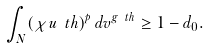Convert formula to latex. <formula><loc_0><loc_0><loc_500><loc_500>\int _ { N } ( \chi u _ { \ } t h ) ^ { p } \, d v ^ { g _ { \ } t h } \geq 1 - d _ { 0 } .</formula> 